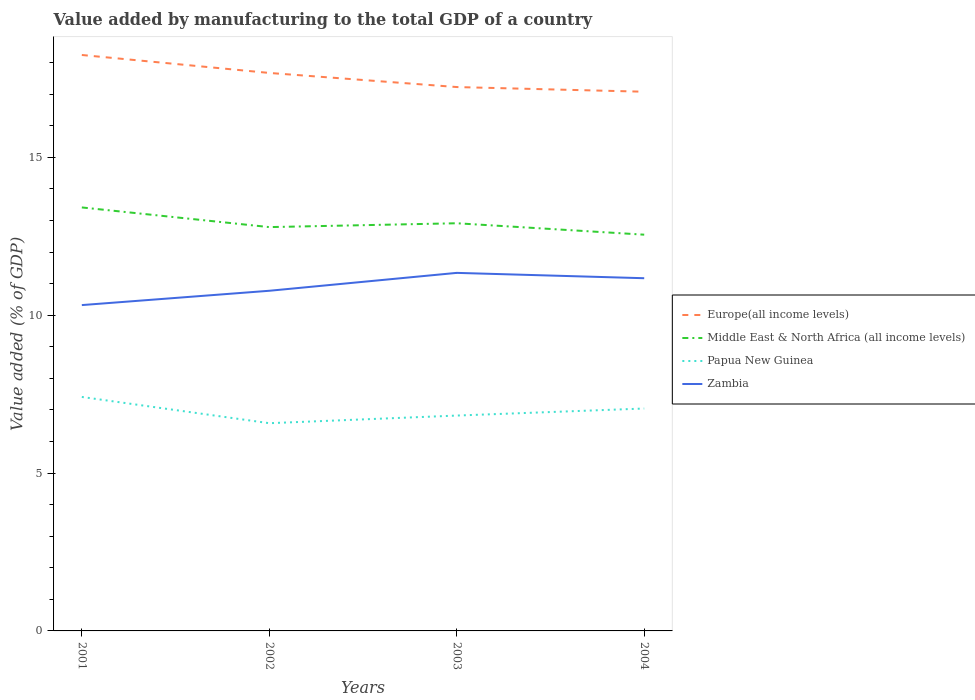Across all years, what is the maximum value added by manufacturing to the total GDP in Papua New Guinea?
Provide a short and direct response. 6.58. What is the total value added by manufacturing to the total GDP in Middle East & North Africa (all income levels) in the graph?
Make the answer very short. 0.5. What is the difference between the highest and the second highest value added by manufacturing to the total GDP in Middle East & North Africa (all income levels)?
Offer a terse response. 0.86. What is the difference between the highest and the lowest value added by manufacturing to the total GDP in Middle East & North Africa (all income levels)?
Provide a short and direct response. 1. Is the value added by manufacturing to the total GDP in Middle East & North Africa (all income levels) strictly greater than the value added by manufacturing to the total GDP in Europe(all income levels) over the years?
Your answer should be compact. Yes. How many years are there in the graph?
Your response must be concise. 4. How many legend labels are there?
Give a very brief answer. 4. How are the legend labels stacked?
Offer a very short reply. Vertical. What is the title of the graph?
Provide a succinct answer. Value added by manufacturing to the total GDP of a country. Does "United Arab Emirates" appear as one of the legend labels in the graph?
Provide a succinct answer. No. What is the label or title of the X-axis?
Offer a terse response. Years. What is the label or title of the Y-axis?
Offer a very short reply. Value added (% of GDP). What is the Value added (% of GDP) of Europe(all income levels) in 2001?
Your answer should be very brief. 18.24. What is the Value added (% of GDP) in Middle East & North Africa (all income levels) in 2001?
Provide a short and direct response. 13.42. What is the Value added (% of GDP) of Papua New Guinea in 2001?
Make the answer very short. 7.41. What is the Value added (% of GDP) in Zambia in 2001?
Offer a very short reply. 10.32. What is the Value added (% of GDP) of Europe(all income levels) in 2002?
Your answer should be compact. 17.68. What is the Value added (% of GDP) of Middle East & North Africa (all income levels) in 2002?
Your answer should be very brief. 12.79. What is the Value added (% of GDP) of Papua New Guinea in 2002?
Provide a short and direct response. 6.58. What is the Value added (% of GDP) of Zambia in 2002?
Offer a very short reply. 10.78. What is the Value added (% of GDP) of Europe(all income levels) in 2003?
Keep it short and to the point. 17.23. What is the Value added (% of GDP) of Middle East & North Africa (all income levels) in 2003?
Keep it short and to the point. 12.91. What is the Value added (% of GDP) of Papua New Guinea in 2003?
Keep it short and to the point. 6.82. What is the Value added (% of GDP) of Zambia in 2003?
Give a very brief answer. 11.34. What is the Value added (% of GDP) in Europe(all income levels) in 2004?
Your response must be concise. 17.08. What is the Value added (% of GDP) of Middle East & North Africa (all income levels) in 2004?
Your response must be concise. 12.55. What is the Value added (% of GDP) in Papua New Guinea in 2004?
Your answer should be very brief. 7.05. What is the Value added (% of GDP) in Zambia in 2004?
Provide a short and direct response. 11.17. Across all years, what is the maximum Value added (% of GDP) of Europe(all income levels)?
Your answer should be compact. 18.24. Across all years, what is the maximum Value added (% of GDP) in Middle East & North Africa (all income levels)?
Give a very brief answer. 13.42. Across all years, what is the maximum Value added (% of GDP) of Papua New Guinea?
Provide a short and direct response. 7.41. Across all years, what is the maximum Value added (% of GDP) in Zambia?
Your response must be concise. 11.34. Across all years, what is the minimum Value added (% of GDP) in Europe(all income levels)?
Make the answer very short. 17.08. Across all years, what is the minimum Value added (% of GDP) in Middle East & North Africa (all income levels)?
Your answer should be compact. 12.55. Across all years, what is the minimum Value added (% of GDP) in Papua New Guinea?
Provide a short and direct response. 6.58. Across all years, what is the minimum Value added (% of GDP) in Zambia?
Keep it short and to the point. 10.32. What is the total Value added (% of GDP) of Europe(all income levels) in the graph?
Your response must be concise. 70.23. What is the total Value added (% of GDP) in Middle East & North Africa (all income levels) in the graph?
Keep it short and to the point. 51.67. What is the total Value added (% of GDP) of Papua New Guinea in the graph?
Offer a very short reply. 27.86. What is the total Value added (% of GDP) in Zambia in the graph?
Keep it short and to the point. 43.61. What is the difference between the Value added (% of GDP) in Europe(all income levels) in 2001 and that in 2002?
Offer a very short reply. 0.57. What is the difference between the Value added (% of GDP) in Middle East & North Africa (all income levels) in 2001 and that in 2002?
Provide a succinct answer. 0.62. What is the difference between the Value added (% of GDP) in Papua New Guinea in 2001 and that in 2002?
Provide a succinct answer. 0.83. What is the difference between the Value added (% of GDP) of Zambia in 2001 and that in 2002?
Offer a very short reply. -0.45. What is the difference between the Value added (% of GDP) of Europe(all income levels) in 2001 and that in 2003?
Ensure brevity in your answer.  1.02. What is the difference between the Value added (% of GDP) of Middle East & North Africa (all income levels) in 2001 and that in 2003?
Ensure brevity in your answer.  0.5. What is the difference between the Value added (% of GDP) of Papua New Guinea in 2001 and that in 2003?
Give a very brief answer. 0.59. What is the difference between the Value added (% of GDP) in Zambia in 2001 and that in 2003?
Ensure brevity in your answer.  -1.02. What is the difference between the Value added (% of GDP) of Europe(all income levels) in 2001 and that in 2004?
Make the answer very short. 1.16. What is the difference between the Value added (% of GDP) in Middle East & North Africa (all income levels) in 2001 and that in 2004?
Your response must be concise. 0.86. What is the difference between the Value added (% of GDP) of Papua New Guinea in 2001 and that in 2004?
Provide a succinct answer. 0.37. What is the difference between the Value added (% of GDP) of Zambia in 2001 and that in 2004?
Give a very brief answer. -0.85. What is the difference between the Value added (% of GDP) in Europe(all income levels) in 2002 and that in 2003?
Make the answer very short. 0.45. What is the difference between the Value added (% of GDP) in Middle East & North Africa (all income levels) in 2002 and that in 2003?
Make the answer very short. -0.12. What is the difference between the Value added (% of GDP) of Papua New Guinea in 2002 and that in 2003?
Make the answer very short. -0.24. What is the difference between the Value added (% of GDP) in Zambia in 2002 and that in 2003?
Your answer should be compact. -0.57. What is the difference between the Value added (% of GDP) of Europe(all income levels) in 2002 and that in 2004?
Your answer should be compact. 0.59. What is the difference between the Value added (% of GDP) of Middle East & North Africa (all income levels) in 2002 and that in 2004?
Offer a terse response. 0.24. What is the difference between the Value added (% of GDP) of Papua New Guinea in 2002 and that in 2004?
Your answer should be compact. -0.47. What is the difference between the Value added (% of GDP) in Zambia in 2002 and that in 2004?
Your response must be concise. -0.4. What is the difference between the Value added (% of GDP) of Europe(all income levels) in 2003 and that in 2004?
Your answer should be very brief. 0.15. What is the difference between the Value added (% of GDP) of Middle East & North Africa (all income levels) in 2003 and that in 2004?
Provide a succinct answer. 0.36. What is the difference between the Value added (% of GDP) in Papua New Guinea in 2003 and that in 2004?
Make the answer very short. -0.22. What is the difference between the Value added (% of GDP) of Zambia in 2003 and that in 2004?
Make the answer very short. 0.17. What is the difference between the Value added (% of GDP) of Europe(all income levels) in 2001 and the Value added (% of GDP) of Middle East & North Africa (all income levels) in 2002?
Provide a succinct answer. 5.45. What is the difference between the Value added (% of GDP) in Europe(all income levels) in 2001 and the Value added (% of GDP) in Papua New Guinea in 2002?
Offer a terse response. 11.66. What is the difference between the Value added (% of GDP) in Europe(all income levels) in 2001 and the Value added (% of GDP) in Zambia in 2002?
Your answer should be very brief. 7.47. What is the difference between the Value added (% of GDP) in Middle East & North Africa (all income levels) in 2001 and the Value added (% of GDP) in Papua New Guinea in 2002?
Make the answer very short. 6.83. What is the difference between the Value added (% of GDP) in Middle East & North Africa (all income levels) in 2001 and the Value added (% of GDP) in Zambia in 2002?
Ensure brevity in your answer.  2.64. What is the difference between the Value added (% of GDP) of Papua New Guinea in 2001 and the Value added (% of GDP) of Zambia in 2002?
Your answer should be compact. -3.36. What is the difference between the Value added (% of GDP) of Europe(all income levels) in 2001 and the Value added (% of GDP) of Middle East & North Africa (all income levels) in 2003?
Ensure brevity in your answer.  5.33. What is the difference between the Value added (% of GDP) of Europe(all income levels) in 2001 and the Value added (% of GDP) of Papua New Guinea in 2003?
Offer a very short reply. 11.42. What is the difference between the Value added (% of GDP) of Europe(all income levels) in 2001 and the Value added (% of GDP) of Zambia in 2003?
Your answer should be very brief. 6.9. What is the difference between the Value added (% of GDP) in Middle East & North Africa (all income levels) in 2001 and the Value added (% of GDP) in Papua New Guinea in 2003?
Offer a terse response. 6.59. What is the difference between the Value added (% of GDP) of Middle East & North Africa (all income levels) in 2001 and the Value added (% of GDP) of Zambia in 2003?
Offer a very short reply. 2.07. What is the difference between the Value added (% of GDP) of Papua New Guinea in 2001 and the Value added (% of GDP) of Zambia in 2003?
Provide a succinct answer. -3.93. What is the difference between the Value added (% of GDP) of Europe(all income levels) in 2001 and the Value added (% of GDP) of Middle East & North Africa (all income levels) in 2004?
Your answer should be very brief. 5.69. What is the difference between the Value added (% of GDP) in Europe(all income levels) in 2001 and the Value added (% of GDP) in Papua New Guinea in 2004?
Ensure brevity in your answer.  11.2. What is the difference between the Value added (% of GDP) of Europe(all income levels) in 2001 and the Value added (% of GDP) of Zambia in 2004?
Provide a succinct answer. 7.07. What is the difference between the Value added (% of GDP) in Middle East & North Africa (all income levels) in 2001 and the Value added (% of GDP) in Papua New Guinea in 2004?
Provide a short and direct response. 6.37. What is the difference between the Value added (% of GDP) in Middle East & North Africa (all income levels) in 2001 and the Value added (% of GDP) in Zambia in 2004?
Your answer should be compact. 2.24. What is the difference between the Value added (% of GDP) in Papua New Guinea in 2001 and the Value added (% of GDP) in Zambia in 2004?
Your response must be concise. -3.76. What is the difference between the Value added (% of GDP) of Europe(all income levels) in 2002 and the Value added (% of GDP) of Middle East & North Africa (all income levels) in 2003?
Provide a short and direct response. 4.76. What is the difference between the Value added (% of GDP) in Europe(all income levels) in 2002 and the Value added (% of GDP) in Papua New Guinea in 2003?
Offer a very short reply. 10.85. What is the difference between the Value added (% of GDP) in Europe(all income levels) in 2002 and the Value added (% of GDP) in Zambia in 2003?
Your response must be concise. 6.33. What is the difference between the Value added (% of GDP) in Middle East & North Africa (all income levels) in 2002 and the Value added (% of GDP) in Papua New Guinea in 2003?
Give a very brief answer. 5.97. What is the difference between the Value added (% of GDP) of Middle East & North Africa (all income levels) in 2002 and the Value added (% of GDP) of Zambia in 2003?
Make the answer very short. 1.45. What is the difference between the Value added (% of GDP) in Papua New Guinea in 2002 and the Value added (% of GDP) in Zambia in 2003?
Your answer should be very brief. -4.76. What is the difference between the Value added (% of GDP) in Europe(all income levels) in 2002 and the Value added (% of GDP) in Middle East & North Africa (all income levels) in 2004?
Your answer should be compact. 5.12. What is the difference between the Value added (% of GDP) in Europe(all income levels) in 2002 and the Value added (% of GDP) in Papua New Guinea in 2004?
Your answer should be compact. 10.63. What is the difference between the Value added (% of GDP) in Europe(all income levels) in 2002 and the Value added (% of GDP) in Zambia in 2004?
Your response must be concise. 6.5. What is the difference between the Value added (% of GDP) in Middle East & North Africa (all income levels) in 2002 and the Value added (% of GDP) in Papua New Guinea in 2004?
Ensure brevity in your answer.  5.75. What is the difference between the Value added (% of GDP) of Middle East & North Africa (all income levels) in 2002 and the Value added (% of GDP) of Zambia in 2004?
Provide a short and direct response. 1.62. What is the difference between the Value added (% of GDP) of Papua New Guinea in 2002 and the Value added (% of GDP) of Zambia in 2004?
Ensure brevity in your answer.  -4.59. What is the difference between the Value added (% of GDP) in Europe(all income levels) in 2003 and the Value added (% of GDP) in Middle East & North Africa (all income levels) in 2004?
Offer a terse response. 4.68. What is the difference between the Value added (% of GDP) of Europe(all income levels) in 2003 and the Value added (% of GDP) of Papua New Guinea in 2004?
Your answer should be compact. 10.18. What is the difference between the Value added (% of GDP) of Europe(all income levels) in 2003 and the Value added (% of GDP) of Zambia in 2004?
Give a very brief answer. 6.06. What is the difference between the Value added (% of GDP) of Middle East & North Africa (all income levels) in 2003 and the Value added (% of GDP) of Papua New Guinea in 2004?
Give a very brief answer. 5.87. What is the difference between the Value added (% of GDP) of Middle East & North Africa (all income levels) in 2003 and the Value added (% of GDP) of Zambia in 2004?
Give a very brief answer. 1.74. What is the difference between the Value added (% of GDP) in Papua New Guinea in 2003 and the Value added (% of GDP) in Zambia in 2004?
Offer a very short reply. -4.35. What is the average Value added (% of GDP) in Europe(all income levels) per year?
Make the answer very short. 17.56. What is the average Value added (% of GDP) of Middle East & North Africa (all income levels) per year?
Your response must be concise. 12.92. What is the average Value added (% of GDP) in Papua New Guinea per year?
Your answer should be compact. 6.96. What is the average Value added (% of GDP) in Zambia per year?
Your response must be concise. 10.9. In the year 2001, what is the difference between the Value added (% of GDP) of Europe(all income levels) and Value added (% of GDP) of Middle East & North Africa (all income levels)?
Your answer should be very brief. 4.83. In the year 2001, what is the difference between the Value added (% of GDP) of Europe(all income levels) and Value added (% of GDP) of Papua New Guinea?
Make the answer very short. 10.83. In the year 2001, what is the difference between the Value added (% of GDP) of Europe(all income levels) and Value added (% of GDP) of Zambia?
Provide a succinct answer. 7.92. In the year 2001, what is the difference between the Value added (% of GDP) of Middle East & North Africa (all income levels) and Value added (% of GDP) of Papua New Guinea?
Make the answer very short. 6. In the year 2001, what is the difference between the Value added (% of GDP) of Middle East & North Africa (all income levels) and Value added (% of GDP) of Zambia?
Your response must be concise. 3.09. In the year 2001, what is the difference between the Value added (% of GDP) in Papua New Guinea and Value added (% of GDP) in Zambia?
Keep it short and to the point. -2.91. In the year 2002, what is the difference between the Value added (% of GDP) in Europe(all income levels) and Value added (% of GDP) in Middle East & North Africa (all income levels)?
Provide a succinct answer. 4.88. In the year 2002, what is the difference between the Value added (% of GDP) of Europe(all income levels) and Value added (% of GDP) of Papua New Guinea?
Your answer should be compact. 11.1. In the year 2002, what is the difference between the Value added (% of GDP) in Europe(all income levels) and Value added (% of GDP) in Zambia?
Your response must be concise. 6.9. In the year 2002, what is the difference between the Value added (% of GDP) in Middle East & North Africa (all income levels) and Value added (% of GDP) in Papua New Guinea?
Provide a succinct answer. 6.21. In the year 2002, what is the difference between the Value added (% of GDP) in Middle East & North Africa (all income levels) and Value added (% of GDP) in Zambia?
Provide a succinct answer. 2.02. In the year 2002, what is the difference between the Value added (% of GDP) of Papua New Guinea and Value added (% of GDP) of Zambia?
Your answer should be compact. -4.2. In the year 2003, what is the difference between the Value added (% of GDP) of Europe(all income levels) and Value added (% of GDP) of Middle East & North Africa (all income levels)?
Offer a very short reply. 4.31. In the year 2003, what is the difference between the Value added (% of GDP) in Europe(all income levels) and Value added (% of GDP) in Papua New Guinea?
Your response must be concise. 10.41. In the year 2003, what is the difference between the Value added (% of GDP) of Europe(all income levels) and Value added (% of GDP) of Zambia?
Keep it short and to the point. 5.89. In the year 2003, what is the difference between the Value added (% of GDP) of Middle East & North Africa (all income levels) and Value added (% of GDP) of Papua New Guinea?
Give a very brief answer. 6.09. In the year 2003, what is the difference between the Value added (% of GDP) of Middle East & North Africa (all income levels) and Value added (% of GDP) of Zambia?
Your response must be concise. 1.57. In the year 2003, what is the difference between the Value added (% of GDP) in Papua New Guinea and Value added (% of GDP) in Zambia?
Your response must be concise. -4.52. In the year 2004, what is the difference between the Value added (% of GDP) in Europe(all income levels) and Value added (% of GDP) in Middle East & North Africa (all income levels)?
Keep it short and to the point. 4.53. In the year 2004, what is the difference between the Value added (% of GDP) in Europe(all income levels) and Value added (% of GDP) in Papua New Guinea?
Offer a very short reply. 10.04. In the year 2004, what is the difference between the Value added (% of GDP) in Europe(all income levels) and Value added (% of GDP) in Zambia?
Keep it short and to the point. 5.91. In the year 2004, what is the difference between the Value added (% of GDP) of Middle East & North Africa (all income levels) and Value added (% of GDP) of Papua New Guinea?
Provide a short and direct response. 5.51. In the year 2004, what is the difference between the Value added (% of GDP) in Middle East & North Africa (all income levels) and Value added (% of GDP) in Zambia?
Your answer should be very brief. 1.38. In the year 2004, what is the difference between the Value added (% of GDP) of Papua New Guinea and Value added (% of GDP) of Zambia?
Provide a succinct answer. -4.13. What is the ratio of the Value added (% of GDP) in Europe(all income levels) in 2001 to that in 2002?
Provide a succinct answer. 1.03. What is the ratio of the Value added (% of GDP) of Middle East & North Africa (all income levels) in 2001 to that in 2002?
Your answer should be compact. 1.05. What is the ratio of the Value added (% of GDP) of Papua New Guinea in 2001 to that in 2002?
Offer a very short reply. 1.13. What is the ratio of the Value added (% of GDP) in Zambia in 2001 to that in 2002?
Your answer should be compact. 0.96. What is the ratio of the Value added (% of GDP) in Europe(all income levels) in 2001 to that in 2003?
Your answer should be very brief. 1.06. What is the ratio of the Value added (% of GDP) of Middle East & North Africa (all income levels) in 2001 to that in 2003?
Offer a terse response. 1.04. What is the ratio of the Value added (% of GDP) in Papua New Guinea in 2001 to that in 2003?
Provide a succinct answer. 1.09. What is the ratio of the Value added (% of GDP) of Zambia in 2001 to that in 2003?
Your answer should be compact. 0.91. What is the ratio of the Value added (% of GDP) in Europe(all income levels) in 2001 to that in 2004?
Your response must be concise. 1.07. What is the ratio of the Value added (% of GDP) in Middle East & North Africa (all income levels) in 2001 to that in 2004?
Your answer should be very brief. 1.07. What is the ratio of the Value added (% of GDP) of Papua New Guinea in 2001 to that in 2004?
Your response must be concise. 1.05. What is the ratio of the Value added (% of GDP) in Zambia in 2001 to that in 2004?
Your response must be concise. 0.92. What is the ratio of the Value added (% of GDP) of Europe(all income levels) in 2002 to that in 2003?
Ensure brevity in your answer.  1.03. What is the ratio of the Value added (% of GDP) in Papua New Guinea in 2002 to that in 2003?
Provide a short and direct response. 0.96. What is the ratio of the Value added (% of GDP) of Europe(all income levels) in 2002 to that in 2004?
Offer a very short reply. 1.03. What is the ratio of the Value added (% of GDP) in Middle East & North Africa (all income levels) in 2002 to that in 2004?
Make the answer very short. 1.02. What is the ratio of the Value added (% of GDP) in Papua New Guinea in 2002 to that in 2004?
Give a very brief answer. 0.93. What is the ratio of the Value added (% of GDP) of Zambia in 2002 to that in 2004?
Make the answer very short. 0.96. What is the ratio of the Value added (% of GDP) of Europe(all income levels) in 2003 to that in 2004?
Offer a very short reply. 1.01. What is the ratio of the Value added (% of GDP) of Middle East & North Africa (all income levels) in 2003 to that in 2004?
Offer a very short reply. 1.03. What is the ratio of the Value added (% of GDP) in Papua New Guinea in 2003 to that in 2004?
Make the answer very short. 0.97. What is the ratio of the Value added (% of GDP) in Zambia in 2003 to that in 2004?
Keep it short and to the point. 1.02. What is the difference between the highest and the second highest Value added (% of GDP) in Europe(all income levels)?
Your answer should be compact. 0.57. What is the difference between the highest and the second highest Value added (% of GDP) of Middle East & North Africa (all income levels)?
Provide a short and direct response. 0.5. What is the difference between the highest and the second highest Value added (% of GDP) of Papua New Guinea?
Give a very brief answer. 0.37. What is the difference between the highest and the second highest Value added (% of GDP) of Zambia?
Provide a succinct answer. 0.17. What is the difference between the highest and the lowest Value added (% of GDP) of Europe(all income levels)?
Give a very brief answer. 1.16. What is the difference between the highest and the lowest Value added (% of GDP) in Middle East & North Africa (all income levels)?
Make the answer very short. 0.86. What is the difference between the highest and the lowest Value added (% of GDP) in Papua New Guinea?
Make the answer very short. 0.83. What is the difference between the highest and the lowest Value added (% of GDP) in Zambia?
Ensure brevity in your answer.  1.02. 